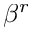Convert formula to latex. <formula><loc_0><loc_0><loc_500><loc_500>\beta ^ { r }</formula> 